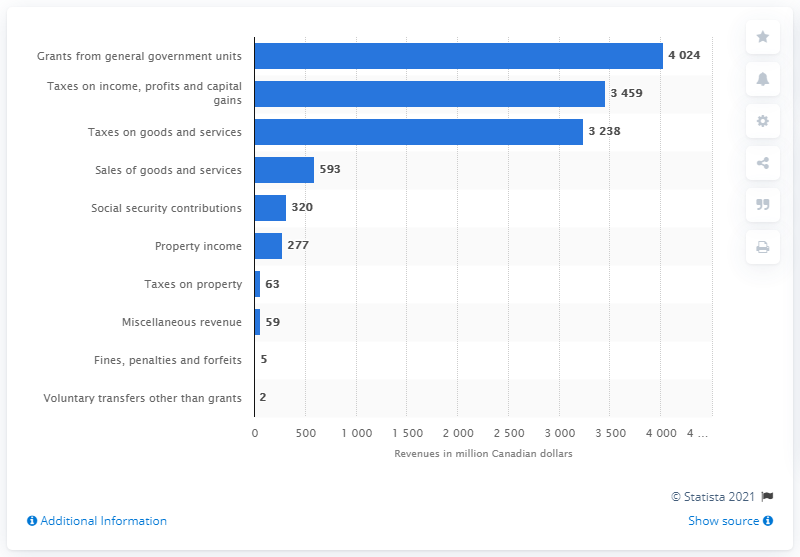Point out several critical features in this image. In 2019, the Nova Scotia government collected approximately CAD 3,238 million in revenue through taxes on goods and services. 